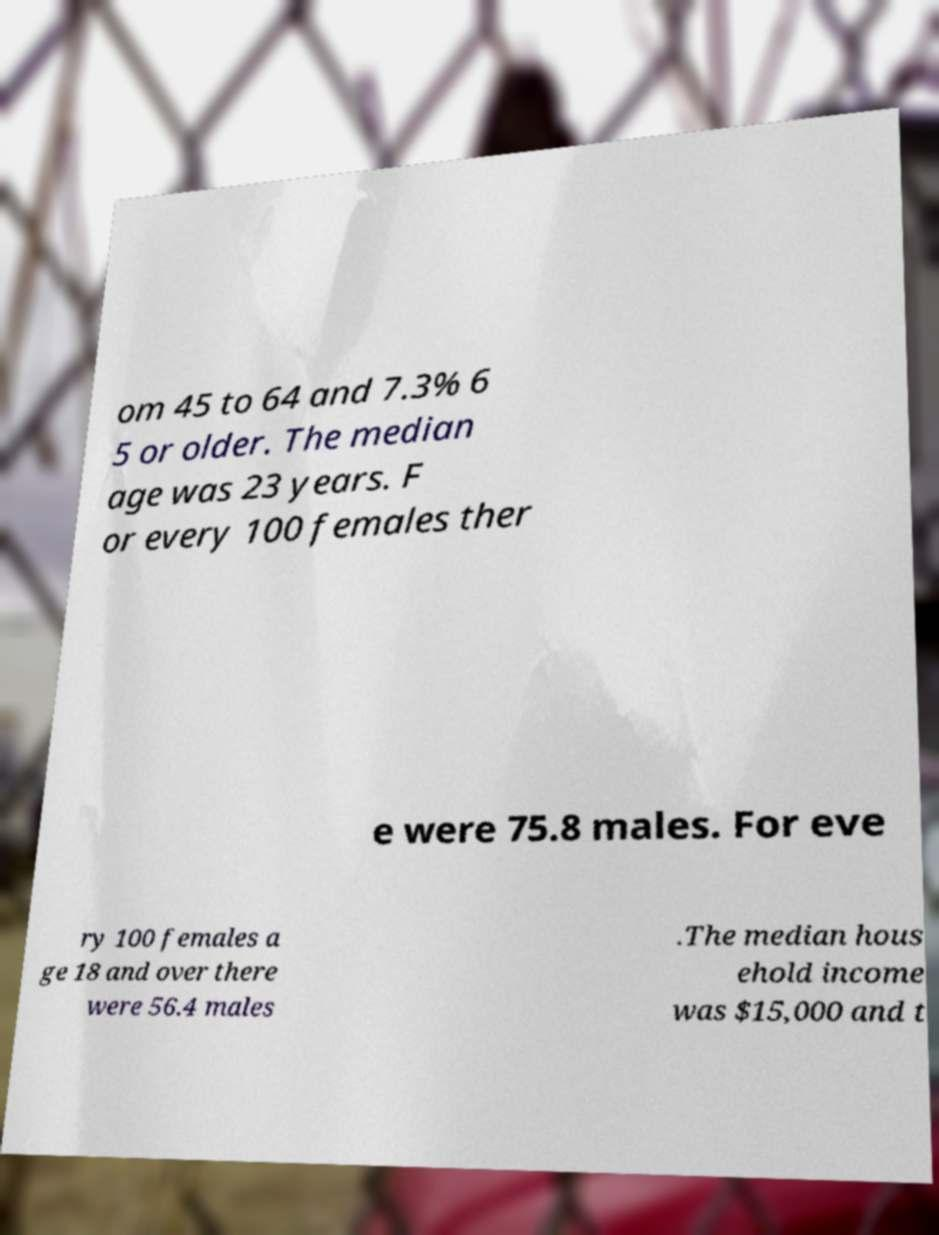Could you extract and type out the text from this image? om 45 to 64 and 7.3% 6 5 or older. The median age was 23 years. F or every 100 females ther e were 75.8 males. For eve ry 100 females a ge 18 and over there were 56.4 males .The median hous ehold income was $15,000 and t 